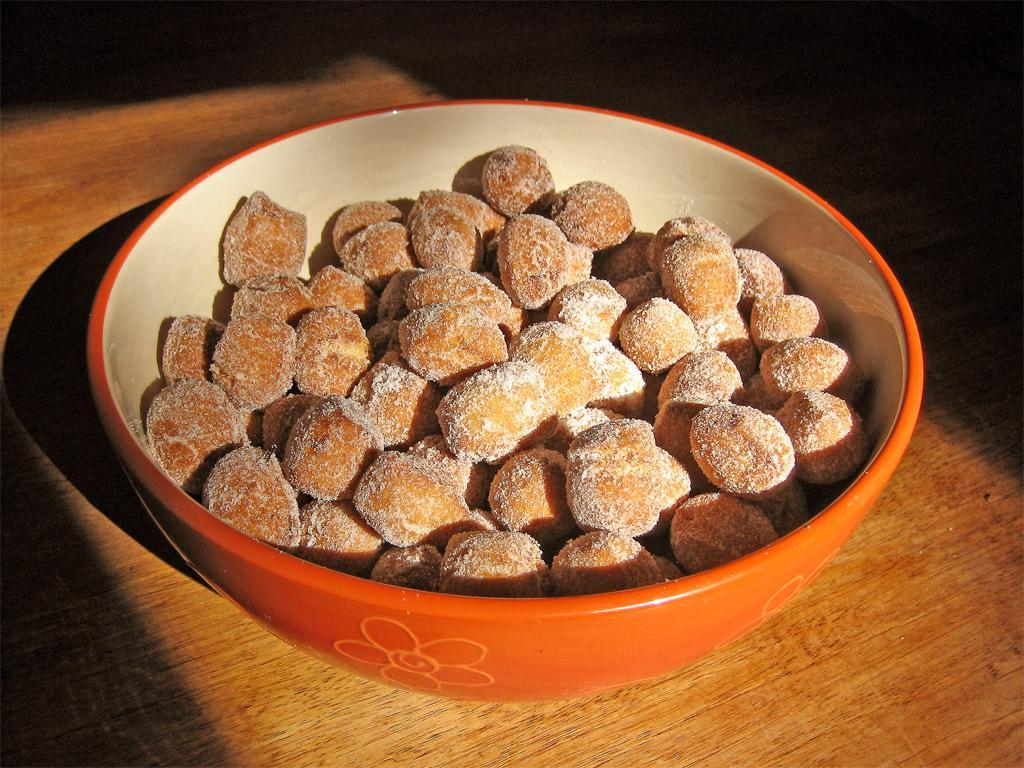What is in the bowl that is visible in the image? There is a food item in a bowl in the image. Where is the bowl located in the image? The bowl is placed on a table. What type of letter can be seen on the hill in the image? There is no hill or letter present in the image; it only features a bowl with a food item placed on a table. 